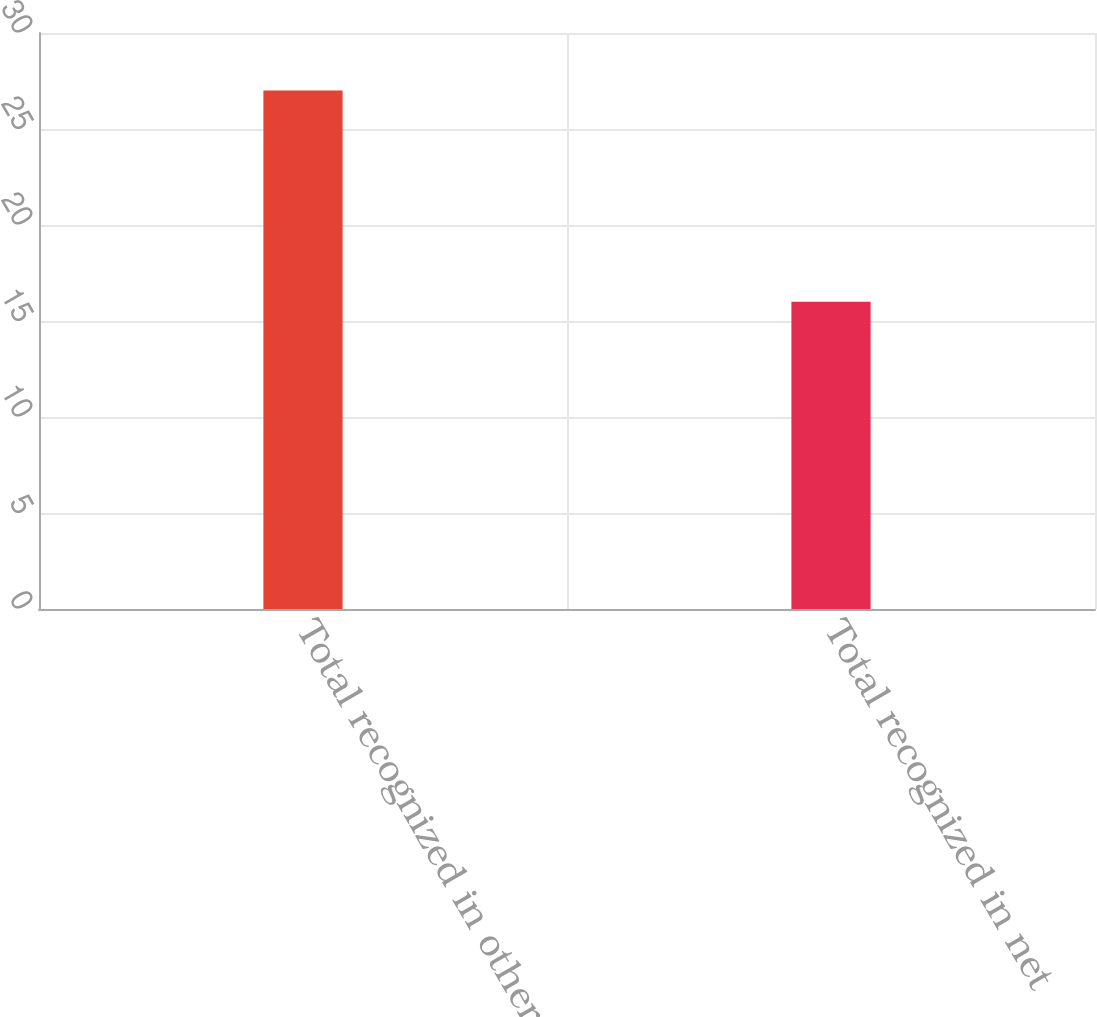Convert chart. <chart><loc_0><loc_0><loc_500><loc_500><bar_chart><fcel>Total recognized in other<fcel>Total recognized in net<nl><fcel>27<fcel>16<nl></chart> 